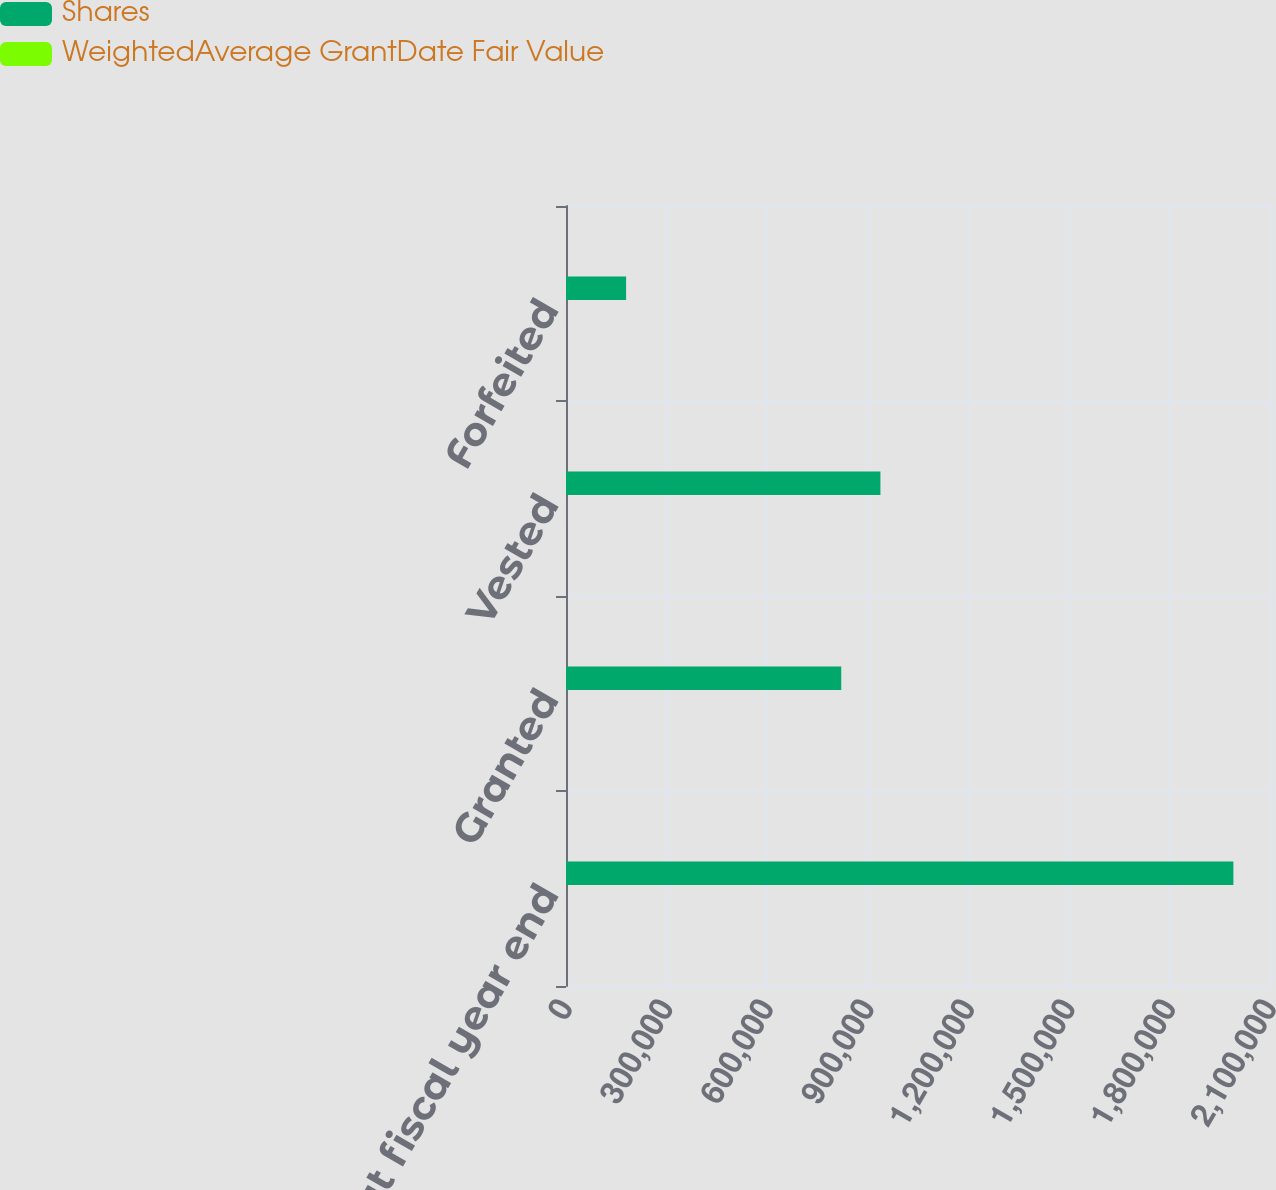Convert chart to OTSL. <chart><loc_0><loc_0><loc_500><loc_500><stacked_bar_chart><ecel><fcel>Nonvested at fiscal year end<fcel>Granted<fcel>Vested<fcel>Forfeited<nl><fcel>Shares<fcel>1.99078e+06<fcel>821016<fcel>937917<fcel>179319<nl><fcel>WeightedAverage GrantDate Fair Value<fcel>64.4<fcel>67.72<fcel>52.89<fcel>63.12<nl></chart> 